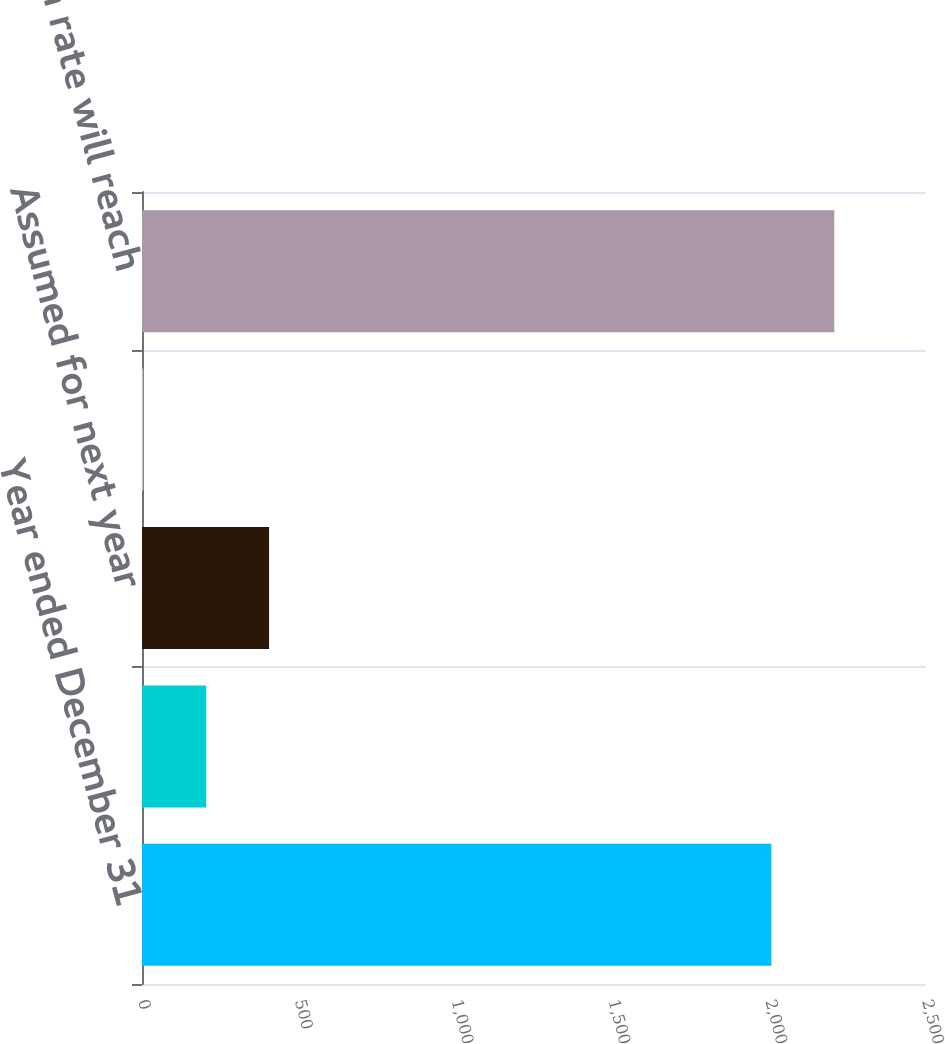Convert chart. <chart><loc_0><loc_0><loc_500><loc_500><bar_chart><fcel>Year ended December 31<fcel>OPEB plans<fcel>Assumed for next year<fcel>Ultimate<fcel>Year when rate will reach<nl><fcel>2007<fcel>204.6<fcel>405.2<fcel>4<fcel>2207.6<nl></chart> 